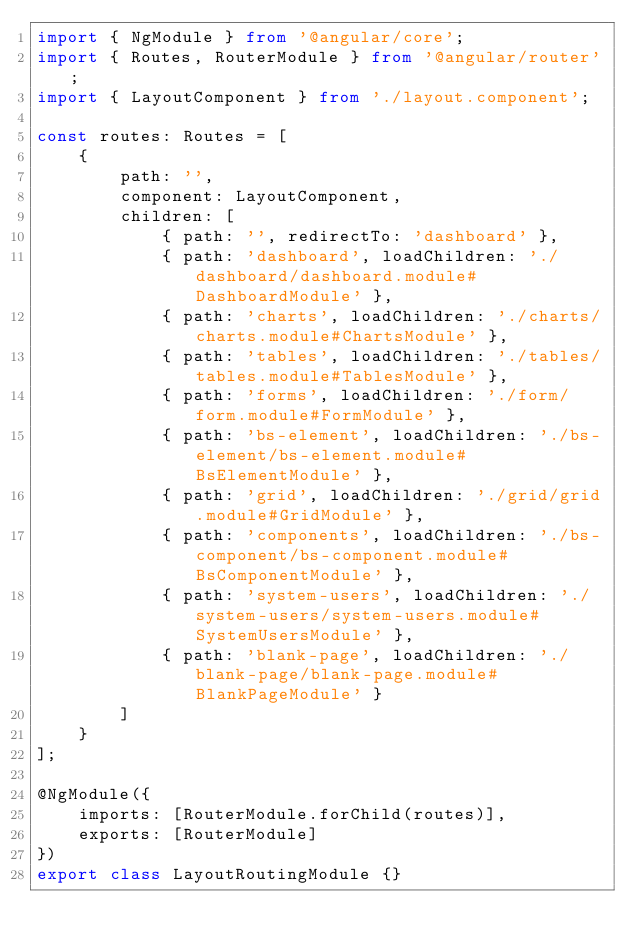Convert code to text. <code><loc_0><loc_0><loc_500><loc_500><_TypeScript_>import { NgModule } from '@angular/core';
import { Routes, RouterModule } from '@angular/router';
import { LayoutComponent } from './layout.component';

const routes: Routes = [
    {
        path: '',
        component: LayoutComponent,
        children: [
            { path: '', redirectTo: 'dashboard' },
            { path: 'dashboard', loadChildren: './dashboard/dashboard.module#DashboardModule' },
            { path: 'charts', loadChildren: './charts/charts.module#ChartsModule' },
            { path: 'tables', loadChildren: './tables/tables.module#TablesModule' },
            { path: 'forms', loadChildren: './form/form.module#FormModule' },
            { path: 'bs-element', loadChildren: './bs-element/bs-element.module#BsElementModule' },
            { path: 'grid', loadChildren: './grid/grid.module#GridModule' },
            { path: 'components', loadChildren: './bs-component/bs-component.module#BsComponentModule' },
            { path: 'system-users', loadChildren: './system-users/system-users.module#SystemUsersModule' },
            { path: 'blank-page', loadChildren: './blank-page/blank-page.module#BlankPageModule' }
        ]
    }
];

@NgModule({
    imports: [RouterModule.forChild(routes)],
    exports: [RouterModule]
})
export class LayoutRoutingModule {}
</code> 